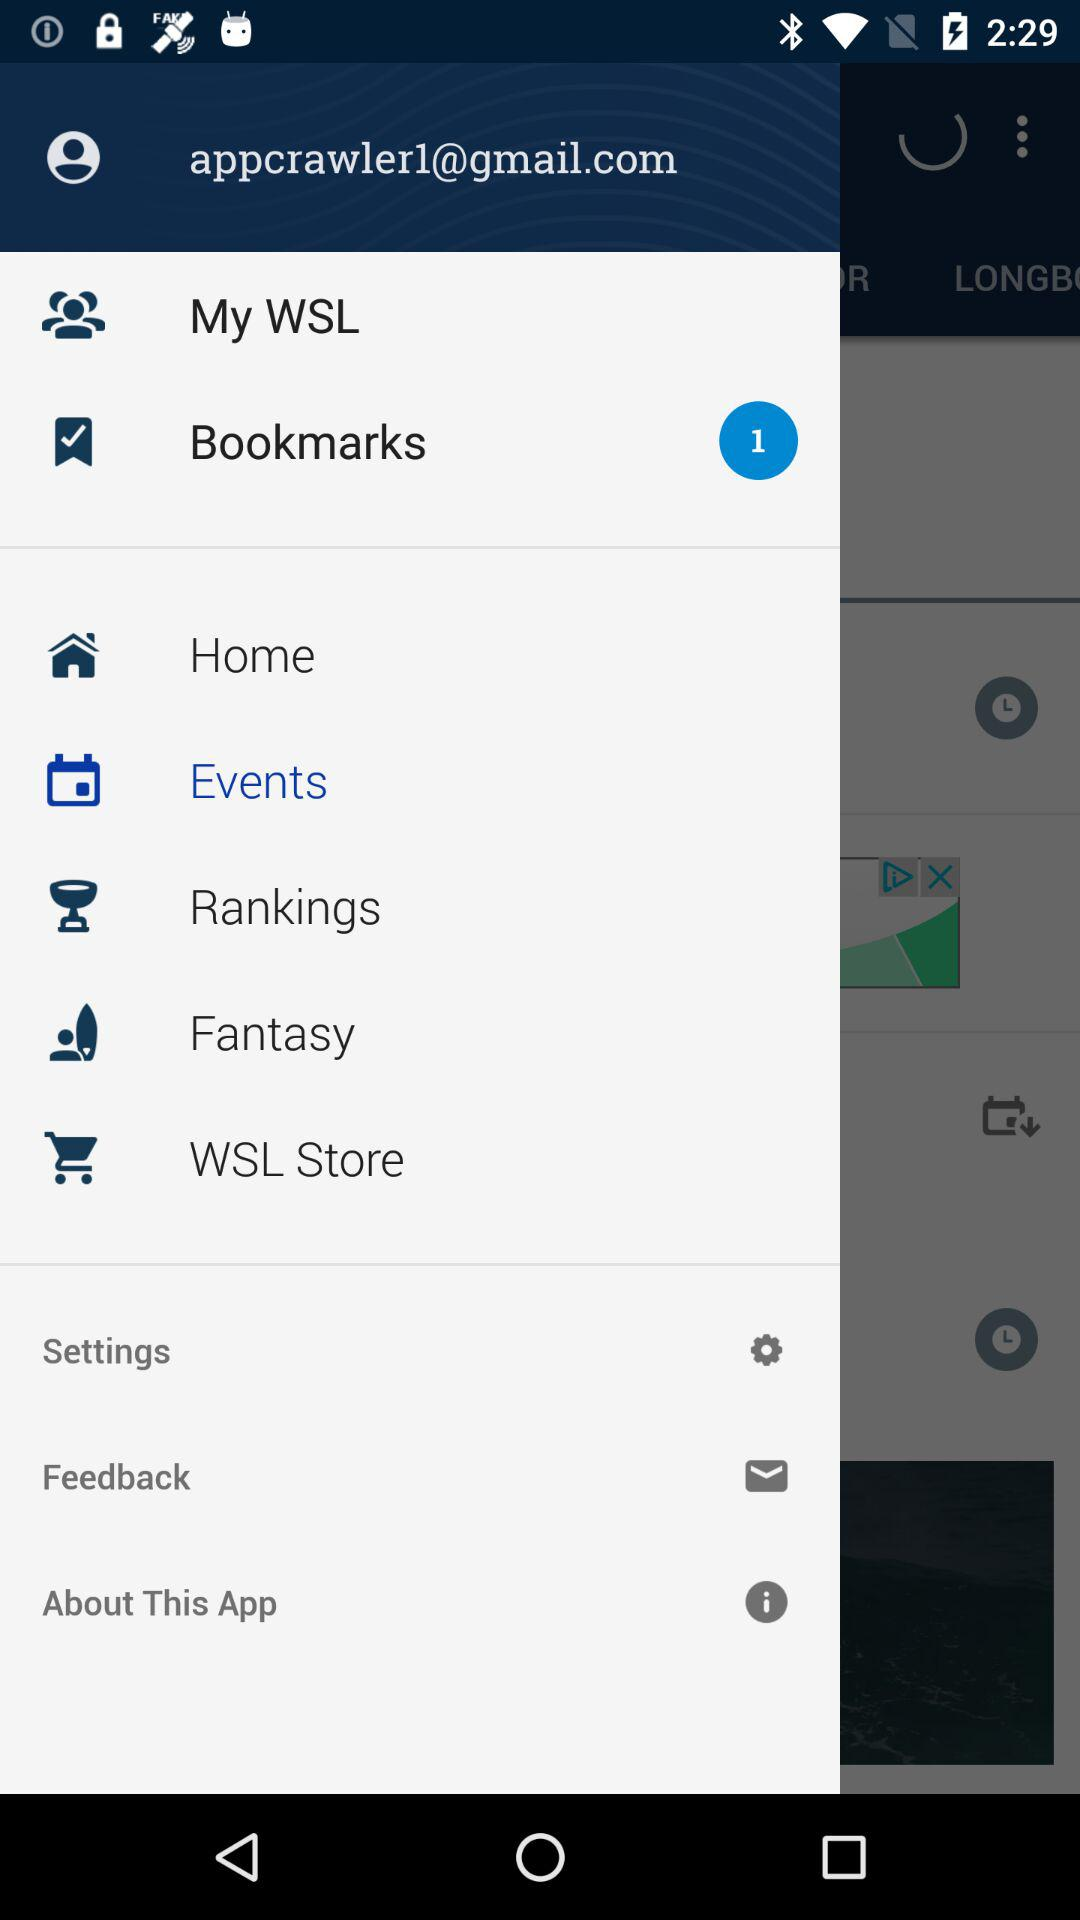What is the email address? The email address is appcrawler1@gmail.com. 